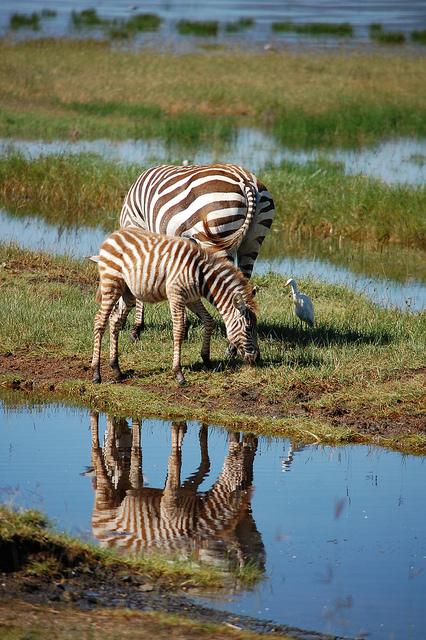How many zebra are in this picture?
Write a very short answer. 2. What kind of bird is that?
Keep it brief. Don't know. How many animals are in the picture?
Quick response, please. 3. Is there water in the picture?
Concise answer only. Yes. Are all the zebras thirsty?
Short answer required. No. 